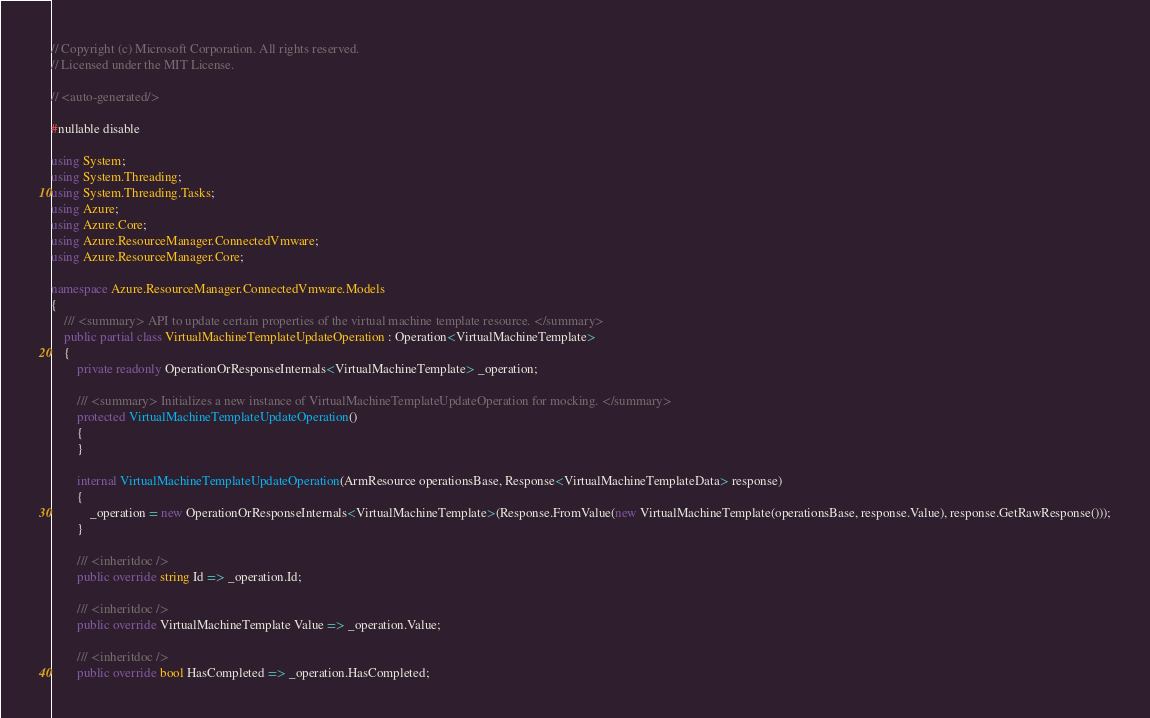<code> <loc_0><loc_0><loc_500><loc_500><_C#_>// Copyright (c) Microsoft Corporation. All rights reserved.
// Licensed under the MIT License.

// <auto-generated/>

#nullable disable

using System;
using System.Threading;
using System.Threading.Tasks;
using Azure;
using Azure.Core;
using Azure.ResourceManager.ConnectedVmware;
using Azure.ResourceManager.Core;

namespace Azure.ResourceManager.ConnectedVmware.Models
{
    /// <summary> API to update certain properties of the virtual machine template resource. </summary>
    public partial class VirtualMachineTemplateUpdateOperation : Operation<VirtualMachineTemplate>
    {
        private readonly OperationOrResponseInternals<VirtualMachineTemplate> _operation;

        /// <summary> Initializes a new instance of VirtualMachineTemplateUpdateOperation for mocking. </summary>
        protected VirtualMachineTemplateUpdateOperation()
        {
        }

        internal VirtualMachineTemplateUpdateOperation(ArmResource operationsBase, Response<VirtualMachineTemplateData> response)
        {
            _operation = new OperationOrResponseInternals<VirtualMachineTemplate>(Response.FromValue(new VirtualMachineTemplate(operationsBase, response.Value), response.GetRawResponse()));
        }

        /// <inheritdoc />
        public override string Id => _operation.Id;

        /// <inheritdoc />
        public override VirtualMachineTemplate Value => _operation.Value;

        /// <inheritdoc />
        public override bool HasCompleted => _operation.HasCompleted;
</code> 